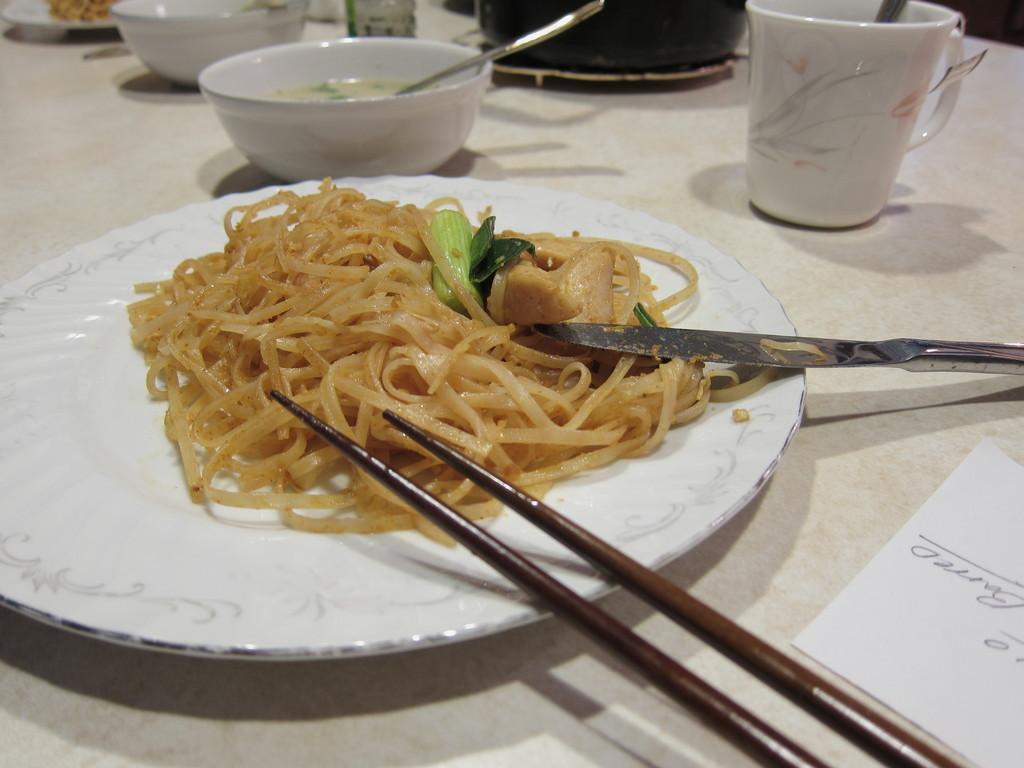Could you give a brief overview of what you see in this image? This is a white plate with some spaghetti food on the plate. These are the chopsticks and knife. This is a table where a cup,bowls, and piece of paper are placed on the table. 